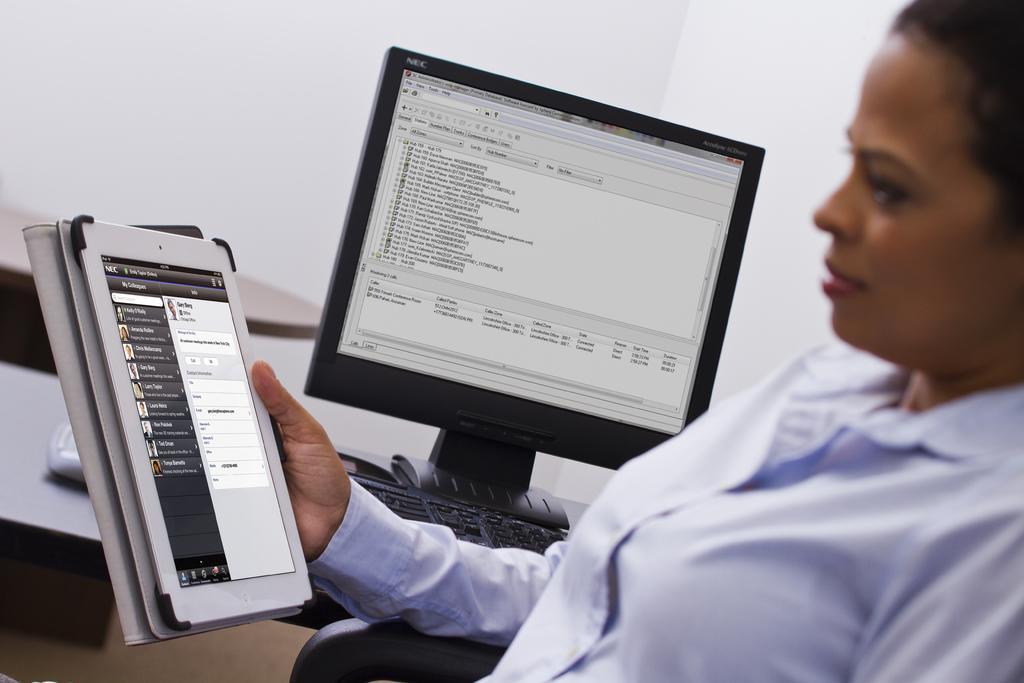How would you summarize this image in a sentence or two? In this image we can see a woman holding the iPad. In the background we can see the monitor and also the keyboard on the table. We can also see the plain wall. 